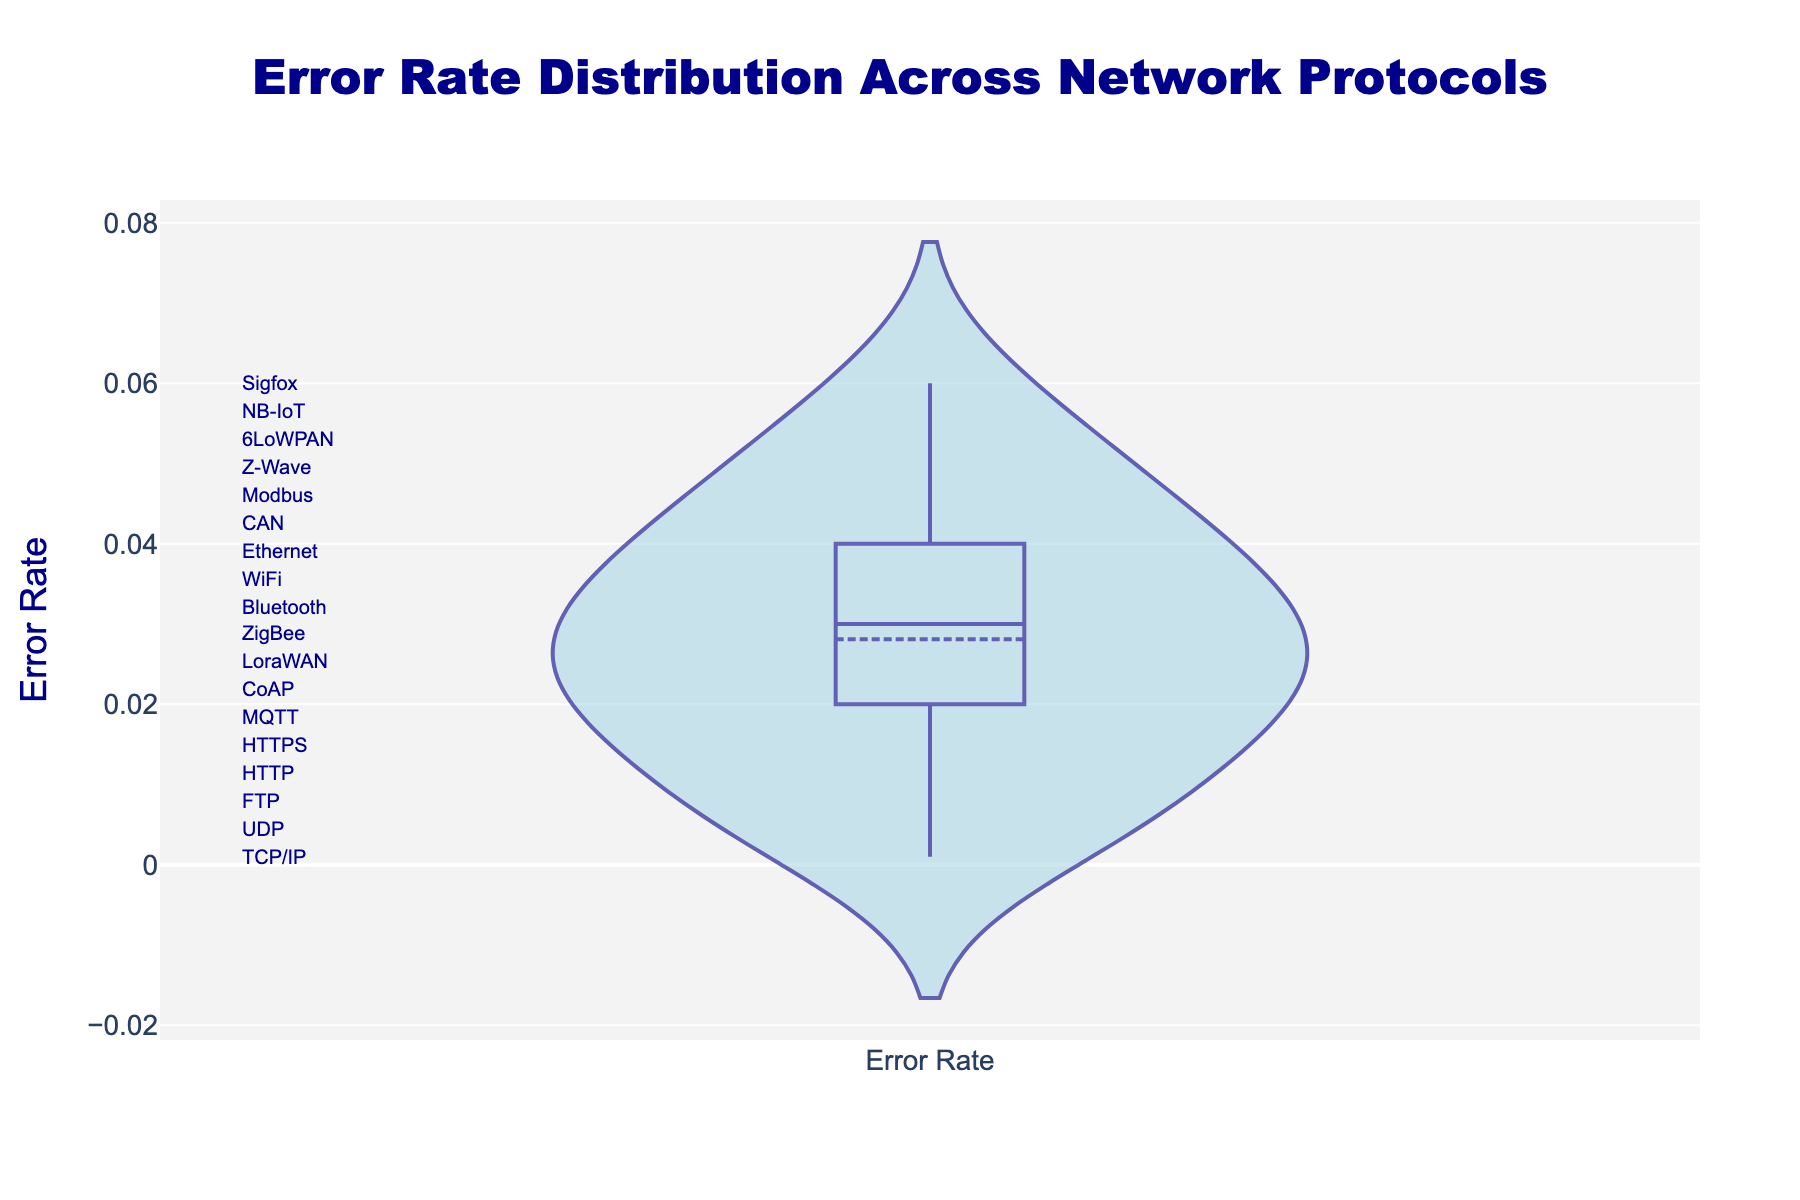What is the title of the plot? The title is prominently displayed at the top of the plot, styled with a large font size and a distinct color for attention.
Answer: Error Rate Distribution Across Network Protocols What does the y-axis represent? The y-axis is labeled with clear text that describes what is being measured in the plot.
Answer: Error Rate What's the minimum error rate observed? The density plot includes data points; identify the lowest point visualized by the distribution.
Answer: 0.001 Which protocol shows the minimum error rate? The density plot includes annotations, and the protocol with the lowest error rate can be found by matching the minimum y-position.
Answer: CAN Which network protocol has the highest error rate? Identify the highest value on the y-axis distribution, then refer to the annotated protocols to find the corresponding one.
Answer: LoraWAN Between which two protocols is the error rate exactly 0.02? Scan the plot to identify the value 0.02 and then note the protocols annotated near that value.
Answer: TCP/IP and MQTT How does the error rate of HTTPS compare to that of HTTP? Locate the positions of HTTPS and HTTP along the y-axis, comparing their respective values.
Answer: HTTPS has a lower error rate What is the average error rate across all protocols? Calculate the total sum of all error rates observed in the plot and then divide by the number of protocols.
Answer: (0.02 + 0.05 + 0.04 + 0.03 + 0.01 + 0.02 + 0.03 + 0.06 + 0.04 + 0.03 + 0.02 + 0.01 + 0.001 + 0.005 + 0.02 + 0.03 + 0.04 + 0.05) / 18 = 0.02717 What is the interquartile range (IQR) of the error rates? First find Q1 (25th percentile) and Q3 (75th percentile) of the error rates distribution, then subtract Q1 from Q3 to get the IQR.
Answer: IQR = Q3 - Q1 = 0.04 - 0.02 = 0.02 How many protocols have an error rate less than the mean error rate? First determine the mean error rate, then count how many protocols have error rates below it by comparing their positions.
Answer: 12 